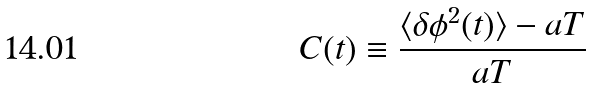<formula> <loc_0><loc_0><loc_500><loc_500>C ( t ) \equiv \frac { \langle \delta \phi ^ { 2 } ( t ) \rangle - a T } { a T }</formula> 